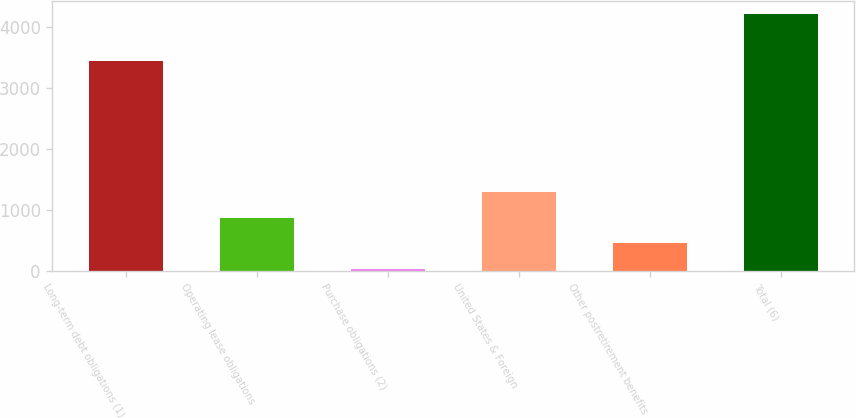<chart> <loc_0><loc_0><loc_500><loc_500><bar_chart><fcel>Long-term debt obligations (1)<fcel>Operating lease obligations<fcel>Purchase obligations (2)<fcel>United States & Foreign<fcel>Other postretirement benefits<fcel>Total (6)<nl><fcel>3447<fcel>872.8<fcel>35<fcel>1291.7<fcel>453.9<fcel>4224<nl></chart> 